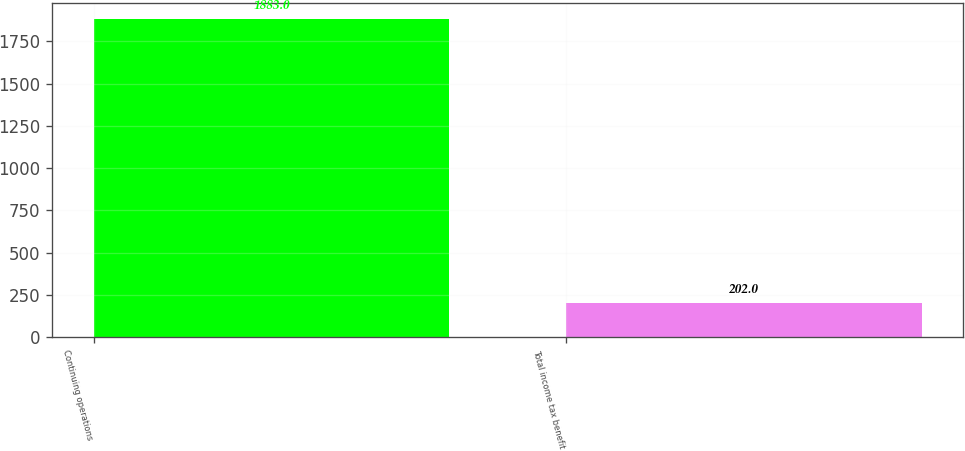Convert chart. <chart><loc_0><loc_0><loc_500><loc_500><bar_chart><fcel>Continuing operations<fcel>Total income tax benefit<nl><fcel>1883<fcel>202<nl></chart> 